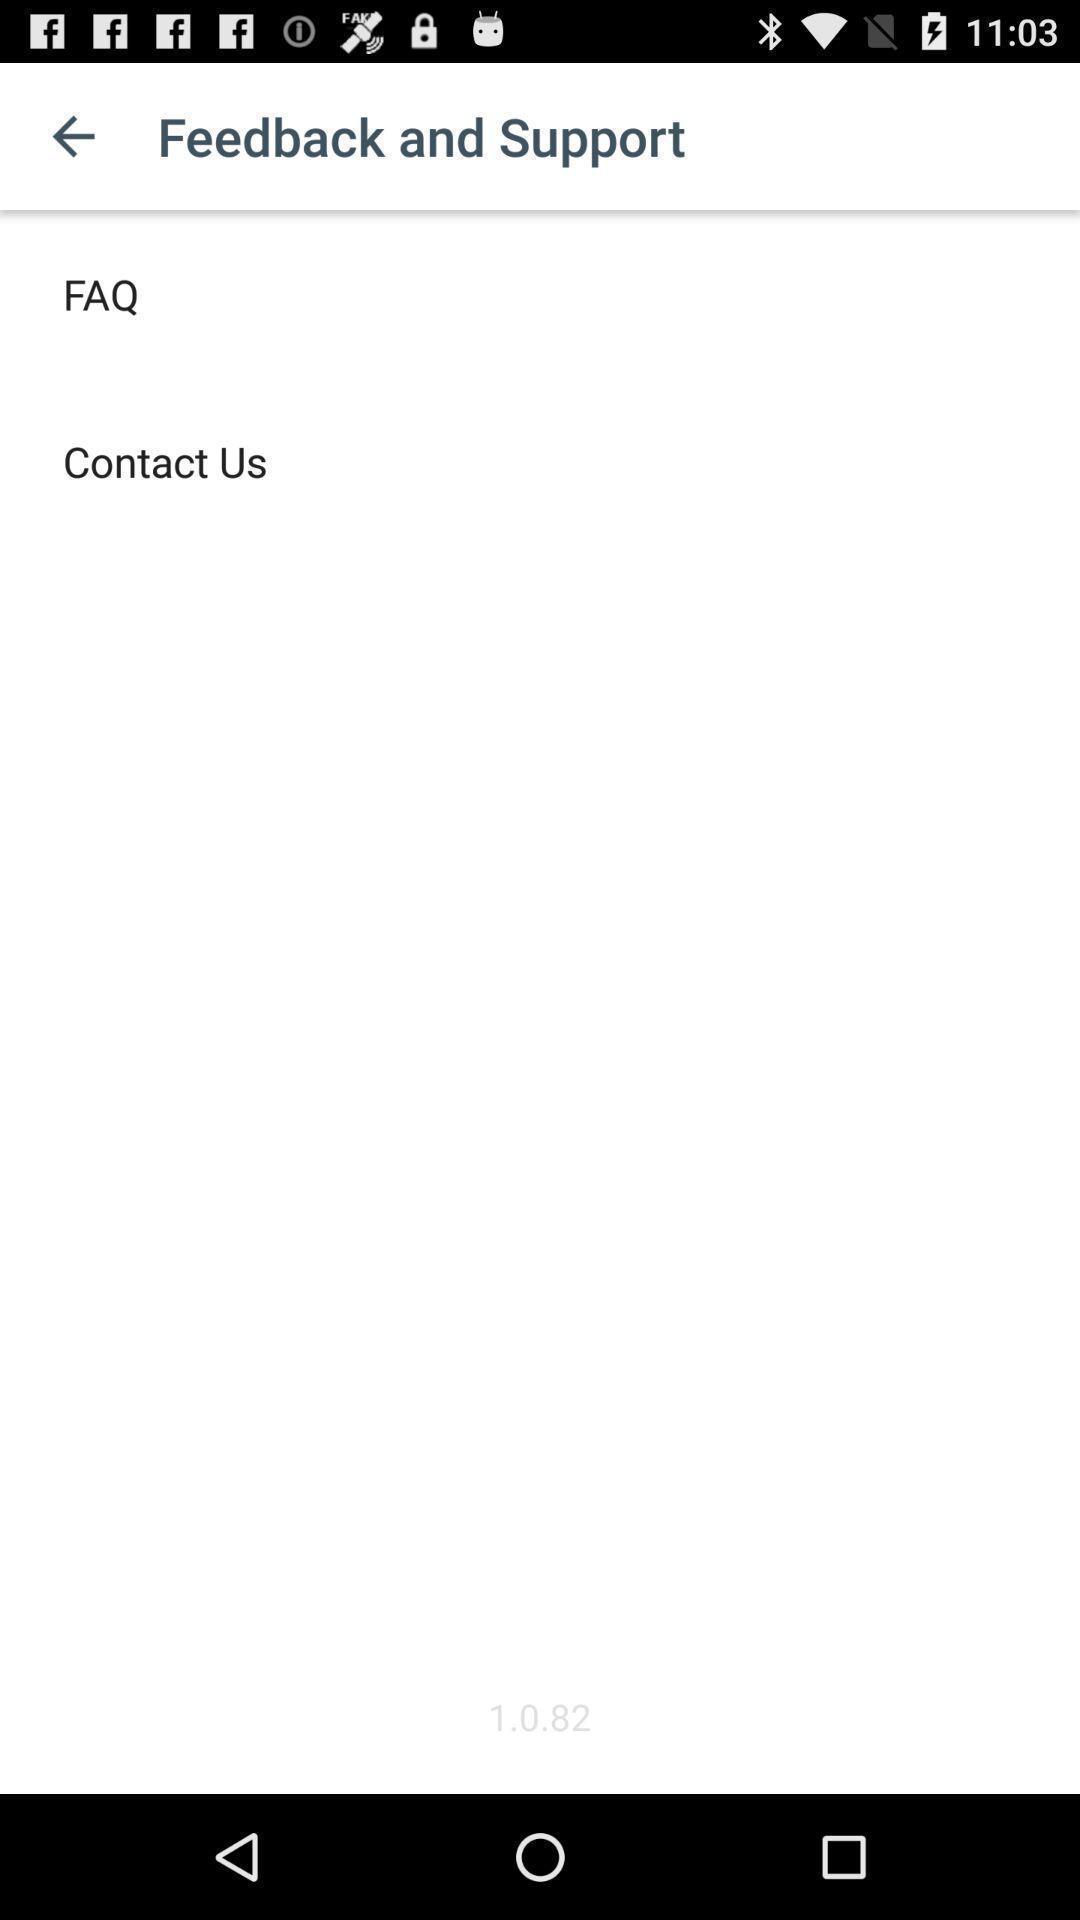Summarize the information in this screenshot. Window displaying a feedback page. 